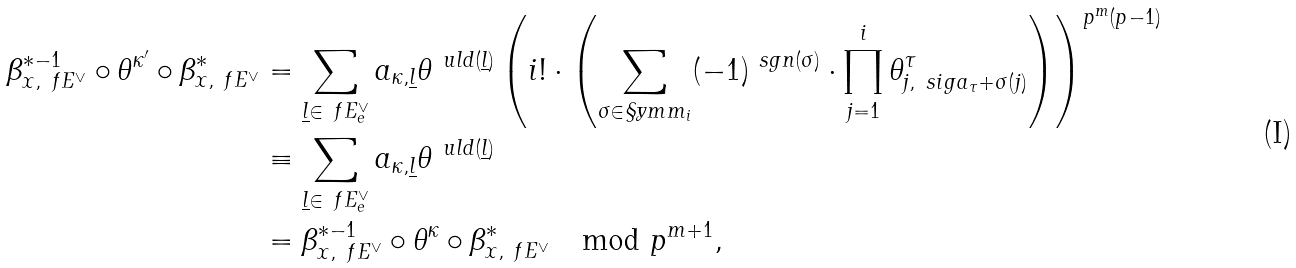Convert formula to latex. <formula><loc_0><loc_0><loc_500><loc_500>\beta _ { x , \ f E ^ { \vee } } ^ { * - 1 } \circ \theta ^ { \kappa ^ { \prime } } \circ \beta _ { x , \ f E ^ { \vee } } ^ { * } & = \sum _ { \underline { l } \in \ f E ^ { \vee } _ { e } } a _ { \kappa , \underline { l } } \theta ^ { \ u l d ( \underline { l } ) } \left ( i ! \cdot \left ( \sum _ { \sigma \in \S y m m _ { i } } ( - 1 ) ^ { \ s g n ( \sigma ) } \cdot \prod _ { j = 1 } ^ { i } \theta ^ { \tau } _ { j , \ s i g a _ { \tau } + \sigma ( j ) } \right ) \right ) ^ { p ^ { m } ( p - 1 ) } \\ & \equiv \sum _ { \underline { l } \in \ f E ^ { \vee } _ { e } } a _ { \kappa , \underline { l } } \theta ^ { \ u l d ( \underline { l } ) } \\ & = \beta _ { x , \ f E ^ { \vee } } ^ { * - 1 } \circ \theta ^ { \kappa } \circ \beta _ { x , \ f E ^ { \vee } } ^ { * } \mod p ^ { m + 1 } ,</formula> 